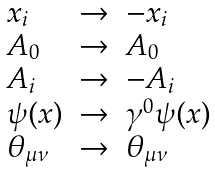Convert formula to latex. <formula><loc_0><loc_0><loc_500><loc_500>\begin{array} { l l l } x _ { i } & \to & - x _ { i } \\ A _ { 0 } & \to & A _ { 0 } \\ A _ { i } & \to & - A _ { i } \\ \psi ( x ) & \to & \gamma ^ { 0 } \psi ( x ) \\ \theta _ { \mu \nu } & \to & \theta _ { \mu \nu } \\ \end{array}</formula> 